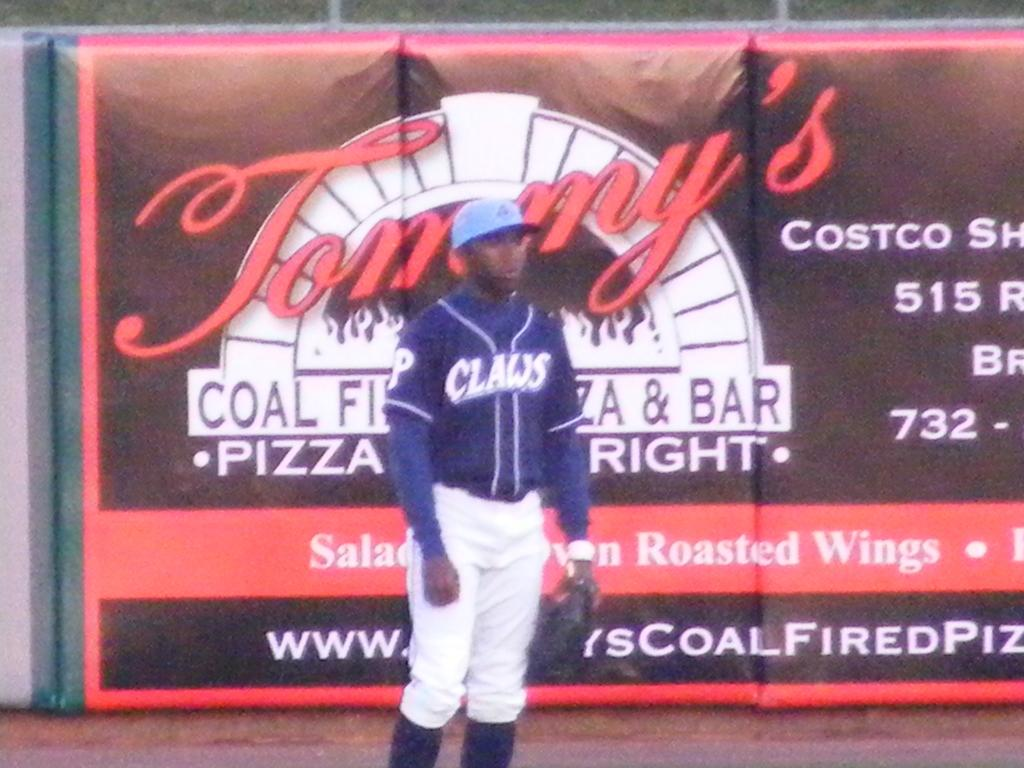<image>
Present a compact description of the photo's key features. A baseball player stands in front of an advertisement for Tommy's pizza restaurant. 